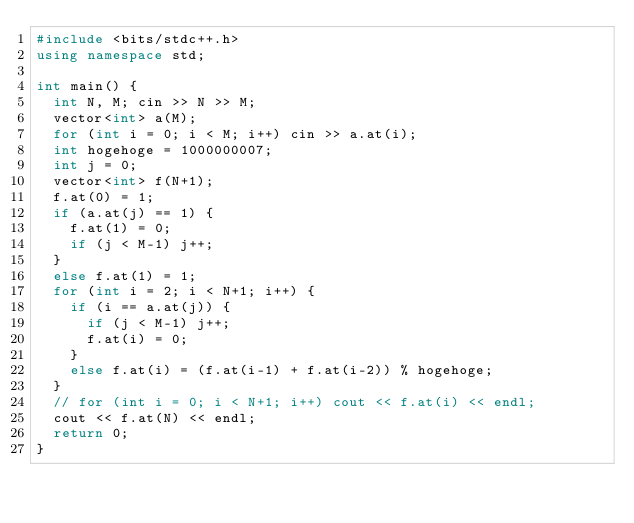Convert code to text. <code><loc_0><loc_0><loc_500><loc_500><_C++_>#include <bits/stdc++.h>
using namespace std;

int main() {
  int N, M; cin >> N >> M;
  vector<int> a(M);
  for (int i = 0; i < M; i++) cin >> a.at(i);
  int hogehoge = 1000000007;
  int j = 0;
  vector<int> f(N+1);
  f.at(0) = 1;
  if (a.at(j) == 1) {
    f.at(1) = 0;
    if (j < M-1) j++;
  }
  else f.at(1) = 1;
  for (int i = 2; i < N+1; i++) {
    if (i == a.at(j)) {
      if (j < M-1) j++;
      f.at(i) = 0;
    }
    else f.at(i) = (f.at(i-1) + f.at(i-2)) % hogehoge;
  }
  // for (int i = 0; i < N+1; i++) cout << f.at(i) << endl;
  cout << f.at(N) << endl;
  return 0;
}</code> 